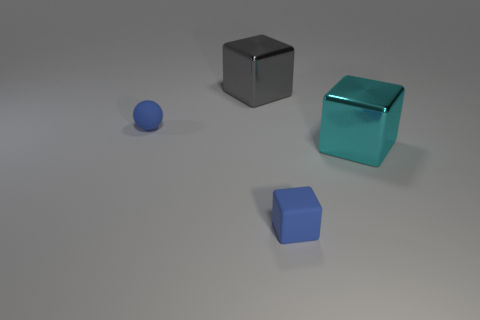Is the number of large cubes that are behind the gray object greater than the number of big cyan objects?
Ensure brevity in your answer.  No. The small cube is what color?
Offer a terse response. Blue. The metallic thing in front of the gray metallic block behind the tiny blue thing to the left of the gray cube is what shape?
Your answer should be compact. Cube. There is a object that is both left of the tiny blue block and on the right side of the small blue rubber ball; what material is it?
Provide a short and direct response. Metal. There is a metallic thing on the right side of the block behind the big cyan block; what shape is it?
Offer a very short reply. Cube. Is there any other thing that has the same color as the tiny rubber ball?
Provide a short and direct response. Yes. There is a blue ball; is it the same size as the shiny thing right of the gray cube?
Your answer should be compact. No. What number of tiny things are cyan shiny cubes or gray metallic blocks?
Keep it short and to the point. 0. Are there more large things than rubber cubes?
Provide a succinct answer. Yes. There is a block to the left of the tiny blue matte thing in front of the cyan shiny thing; what number of cubes are right of it?
Give a very brief answer. 2. 